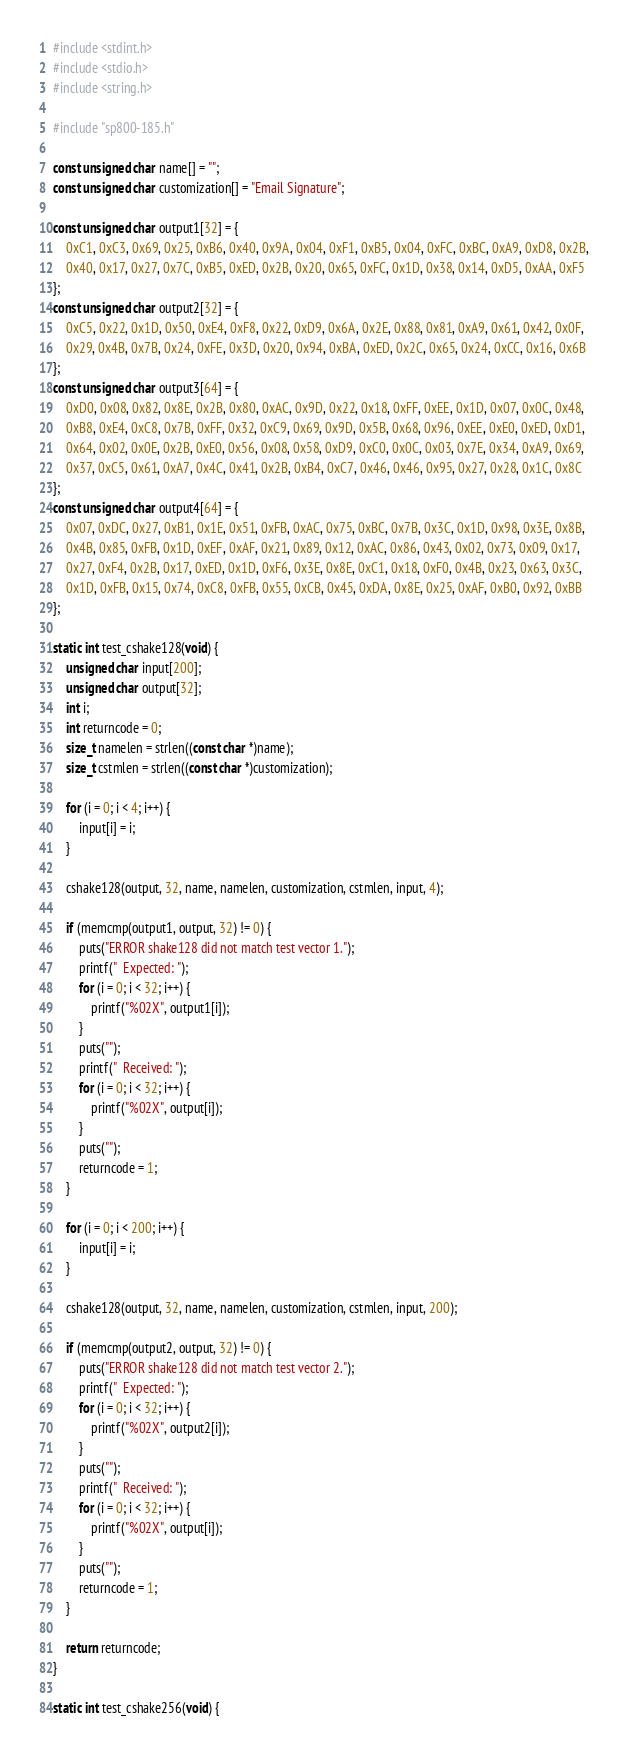Convert code to text. <code><loc_0><loc_0><loc_500><loc_500><_C_>#include <stdint.h>
#include <stdio.h>
#include <string.h>

#include "sp800-185.h"

const unsigned char name[] = "";
const unsigned char customization[] = "Email Signature";

const unsigned char output1[32] = {
    0xC1, 0xC3, 0x69, 0x25, 0xB6, 0x40, 0x9A, 0x04, 0xF1, 0xB5, 0x04, 0xFC, 0xBC, 0xA9, 0xD8, 0x2B,
    0x40, 0x17, 0x27, 0x7C, 0xB5, 0xED, 0x2B, 0x20, 0x65, 0xFC, 0x1D, 0x38, 0x14, 0xD5, 0xAA, 0xF5
};
const unsigned char output2[32] = {
    0xC5, 0x22, 0x1D, 0x50, 0xE4, 0xF8, 0x22, 0xD9, 0x6A, 0x2E, 0x88, 0x81, 0xA9, 0x61, 0x42, 0x0F,
    0x29, 0x4B, 0x7B, 0x24, 0xFE, 0x3D, 0x20, 0x94, 0xBA, 0xED, 0x2C, 0x65, 0x24, 0xCC, 0x16, 0x6B
};
const unsigned char output3[64] = {
    0xD0, 0x08, 0x82, 0x8E, 0x2B, 0x80, 0xAC, 0x9D, 0x22, 0x18, 0xFF, 0xEE, 0x1D, 0x07, 0x0C, 0x48,
    0xB8, 0xE4, 0xC8, 0x7B, 0xFF, 0x32, 0xC9, 0x69, 0x9D, 0x5B, 0x68, 0x96, 0xEE, 0xE0, 0xED, 0xD1,
    0x64, 0x02, 0x0E, 0x2B, 0xE0, 0x56, 0x08, 0x58, 0xD9, 0xC0, 0x0C, 0x03, 0x7E, 0x34, 0xA9, 0x69,
    0x37, 0xC5, 0x61, 0xA7, 0x4C, 0x41, 0x2B, 0xB4, 0xC7, 0x46, 0x46, 0x95, 0x27, 0x28, 0x1C, 0x8C
};
const unsigned char output4[64] = {
    0x07, 0xDC, 0x27, 0xB1, 0x1E, 0x51, 0xFB, 0xAC, 0x75, 0xBC, 0x7B, 0x3C, 0x1D, 0x98, 0x3E, 0x8B,
    0x4B, 0x85, 0xFB, 0x1D, 0xEF, 0xAF, 0x21, 0x89, 0x12, 0xAC, 0x86, 0x43, 0x02, 0x73, 0x09, 0x17,
    0x27, 0xF4, 0x2B, 0x17, 0xED, 0x1D, 0xF6, 0x3E, 0x8E, 0xC1, 0x18, 0xF0, 0x4B, 0x23, 0x63, 0x3C,
    0x1D, 0xFB, 0x15, 0x74, 0xC8, 0xFB, 0x55, 0xCB, 0x45, 0xDA, 0x8E, 0x25, 0xAF, 0xB0, 0x92, 0xBB
};

static int test_cshake128(void) {
    unsigned char input[200];
    unsigned char output[32];
    int i;
    int returncode = 0;
    size_t namelen = strlen((const char *)name);
    size_t cstmlen = strlen((const char *)customization);

    for (i = 0; i < 4; i++) {
        input[i] = i;
    }

    cshake128(output, 32, name, namelen, customization, cstmlen, input, 4);

    if (memcmp(output1, output, 32) != 0) {
        puts("ERROR shake128 did not match test vector 1.");
        printf("  Expected: ");
        for (i = 0; i < 32; i++) {
            printf("%02X", output1[i]);
        }
        puts("");
        printf("  Received: ");
        for (i = 0; i < 32; i++) {
            printf("%02X", output[i]);
        }
        puts("");
        returncode = 1;
    }

    for (i = 0; i < 200; i++) {
        input[i] = i;
    }

    cshake128(output, 32, name, namelen, customization, cstmlen, input, 200);

    if (memcmp(output2, output, 32) != 0) {
        puts("ERROR shake128 did not match test vector 2.");
        printf("  Expected: ");
        for (i = 0; i < 32; i++) {
            printf("%02X", output2[i]);
        }
        puts("");
        printf("  Received: ");
        for (i = 0; i < 32; i++) {
            printf("%02X", output[i]);
        }
        puts("");
        returncode = 1;
    }

    return returncode;
}

static int test_cshake256(void) {</code> 